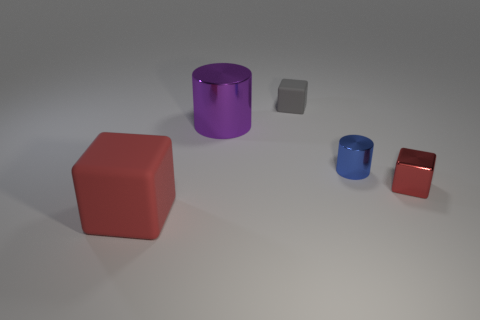Are any tiny green blocks visible?
Give a very brief answer. No. What size is the block that is both to the right of the big purple metallic cylinder and left of the tiny shiny cube?
Give a very brief answer. Small. What is the shape of the blue thing?
Give a very brief answer. Cylinder. Is there a matte cube that is right of the red cube that is on the left side of the red metallic cube?
Offer a terse response. Yes. There is a blue cylinder that is the same size as the gray rubber thing; what is its material?
Your response must be concise. Metal. Is there a red matte cylinder that has the same size as the blue object?
Offer a terse response. No. There is a gray cube that is behind the tiny red metal block; what material is it?
Your response must be concise. Rubber. Are the block that is on the right side of the small gray object and the gray object made of the same material?
Keep it short and to the point. No. What is the shape of the other metallic thing that is the same size as the red metal object?
Your response must be concise. Cylinder. How many big rubber things are the same color as the small metallic cube?
Provide a short and direct response. 1. 